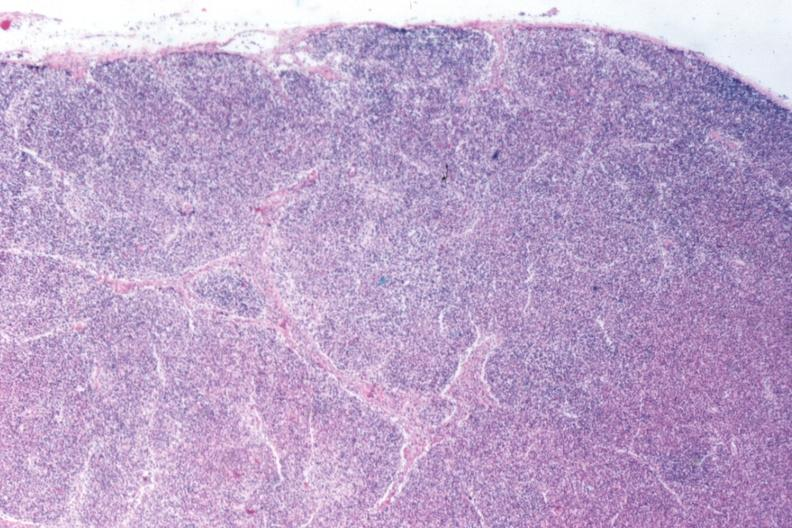what appears to have changed into a blast crisis?
Answer the question using a single word or phrase. Total effacement case 